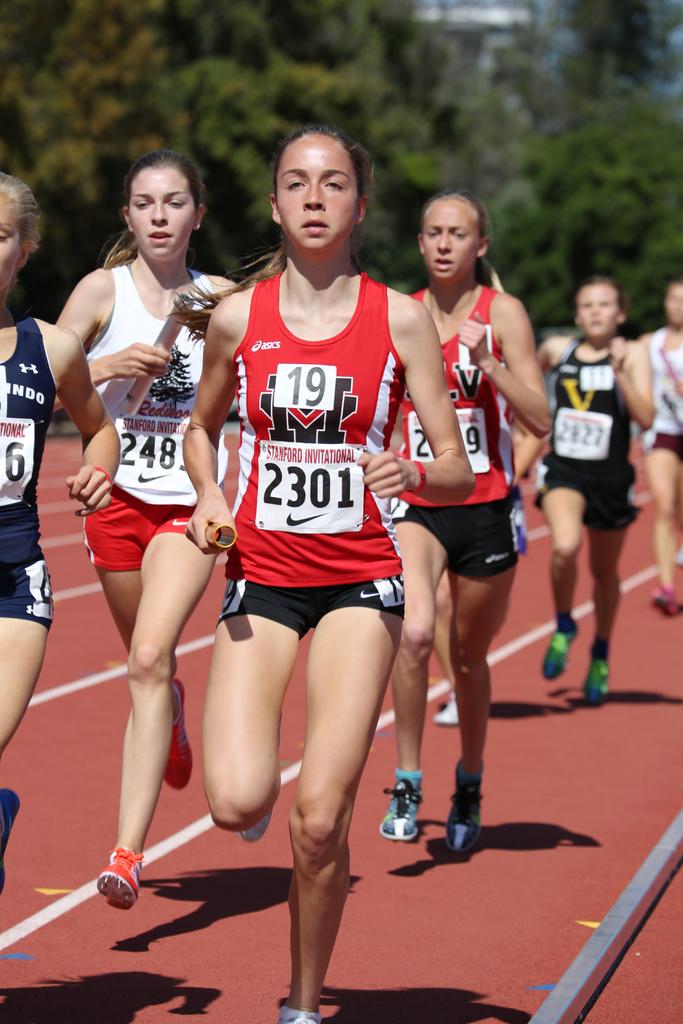Is number 19 in a race or gym class?
Provide a short and direct response. Race. What four digit number is on the front runner's shirt?
Keep it short and to the point. 2301. 